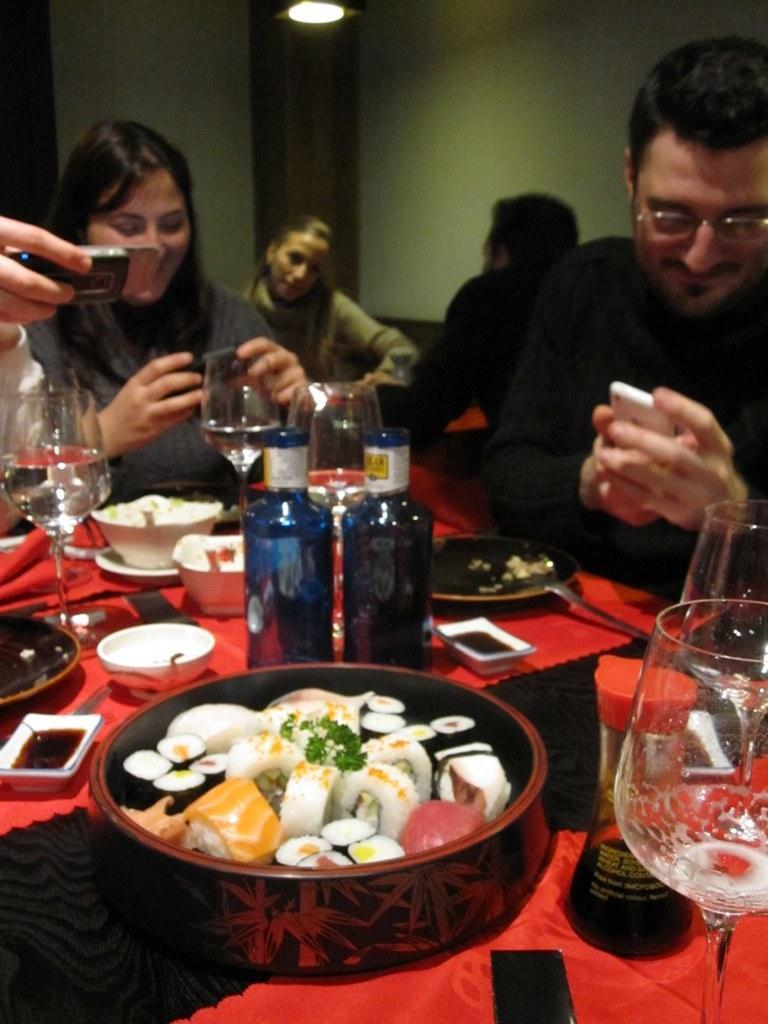How would you summarize this image in a sentence or two? In this picture we can see a group of people sitting on chairs holding mobiles in their hands and looking at it and in front of them there is table and on table we can see bowl, bottles, glass, with some food items and in background we can see wall, light. 